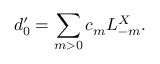<formula> <loc_0><loc_0><loc_500><loc_500>d _ { 0 } ^ { \prime } = \sum _ { m > 0 } c _ { m } L _ { - m } ^ { X } .</formula> 